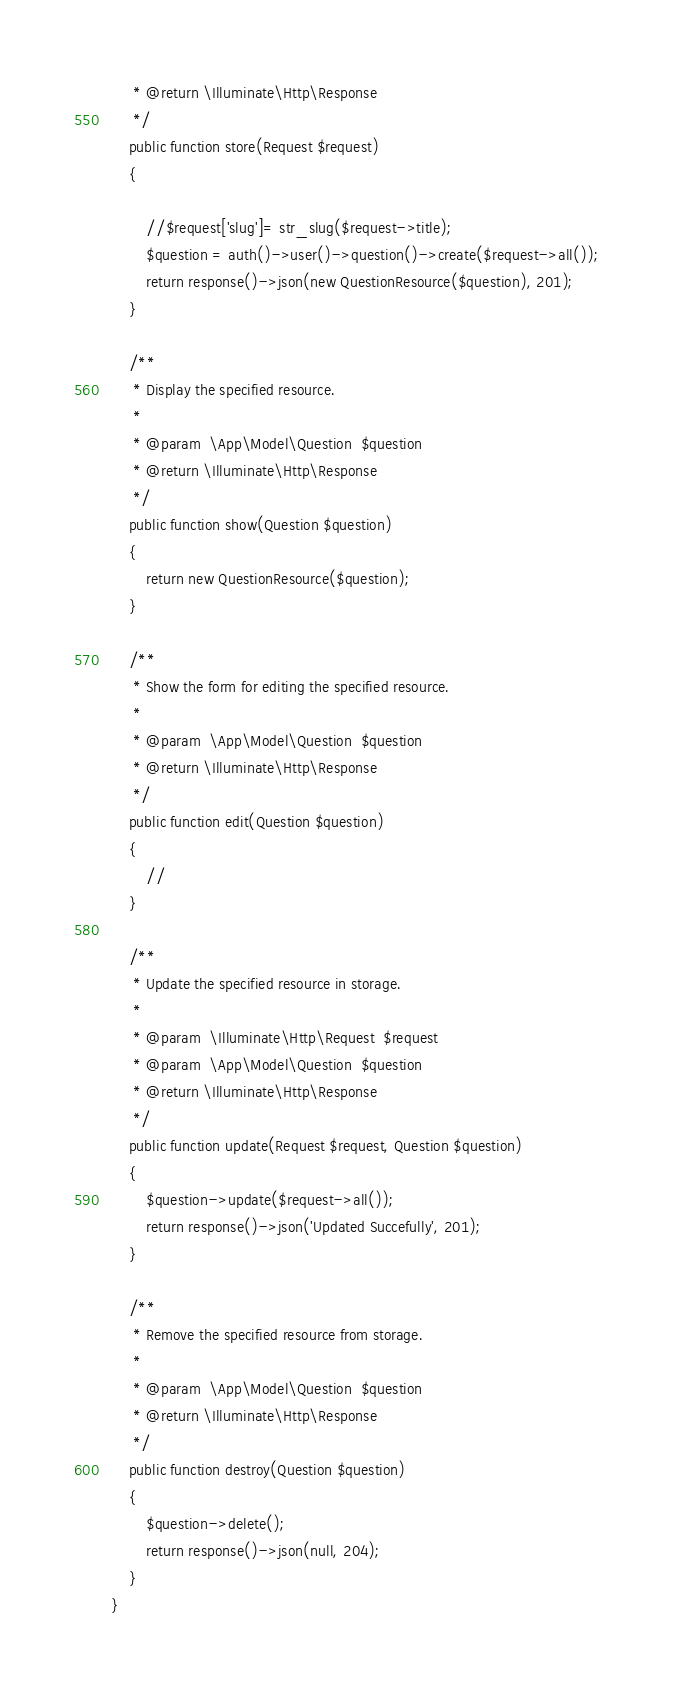Convert code to text. <code><loc_0><loc_0><loc_500><loc_500><_PHP_>     * @return \Illuminate\Http\Response
     */
    public function store(Request $request)
    {
        
        //$request['slug']= str_slug($request->title);
        $question = auth()->user()->question()->create($request->all());
        return response()->json(new QuestionResource($question), 201);
    }

    /**
     * Display the specified resource.
     *
     * @param  \App\Model\Question  $question
     * @return \Illuminate\Http\Response
     */
    public function show(Question $question)
    {
        return new QuestionResource($question);
    }

    /**
     * Show the form for editing the specified resource.
     *
     * @param  \App\Model\Question  $question
     * @return \Illuminate\Http\Response
     */
    public function edit(Question $question)
    {
        //
    }

    /**
     * Update the specified resource in storage.
     *
     * @param  \Illuminate\Http\Request  $request
     * @param  \App\Model\Question  $question
     * @return \Illuminate\Http\Response
     */
    public function update(Request $request, Question $question)
    {
        $question->update($request->all());
        return response()->json('Updated Succefully', 201);
    }

    /**
     * Remove the specified resource from storage.
     *
     * @param  \App\Model\Question  $question
     * @return \Illuminate\Http\Response
     */
    public function destroy(Question $question)
    {
        $question->delete();
        return response()->json(null, 204);
    }
}
</code> 